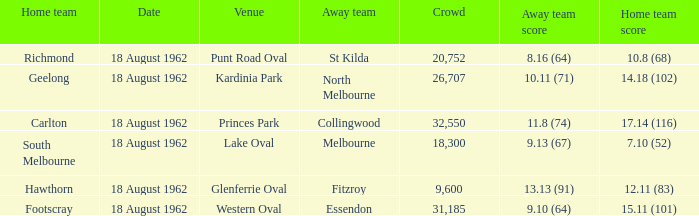What was the home team when the away team scored 9.10 (64)? Footscray. 